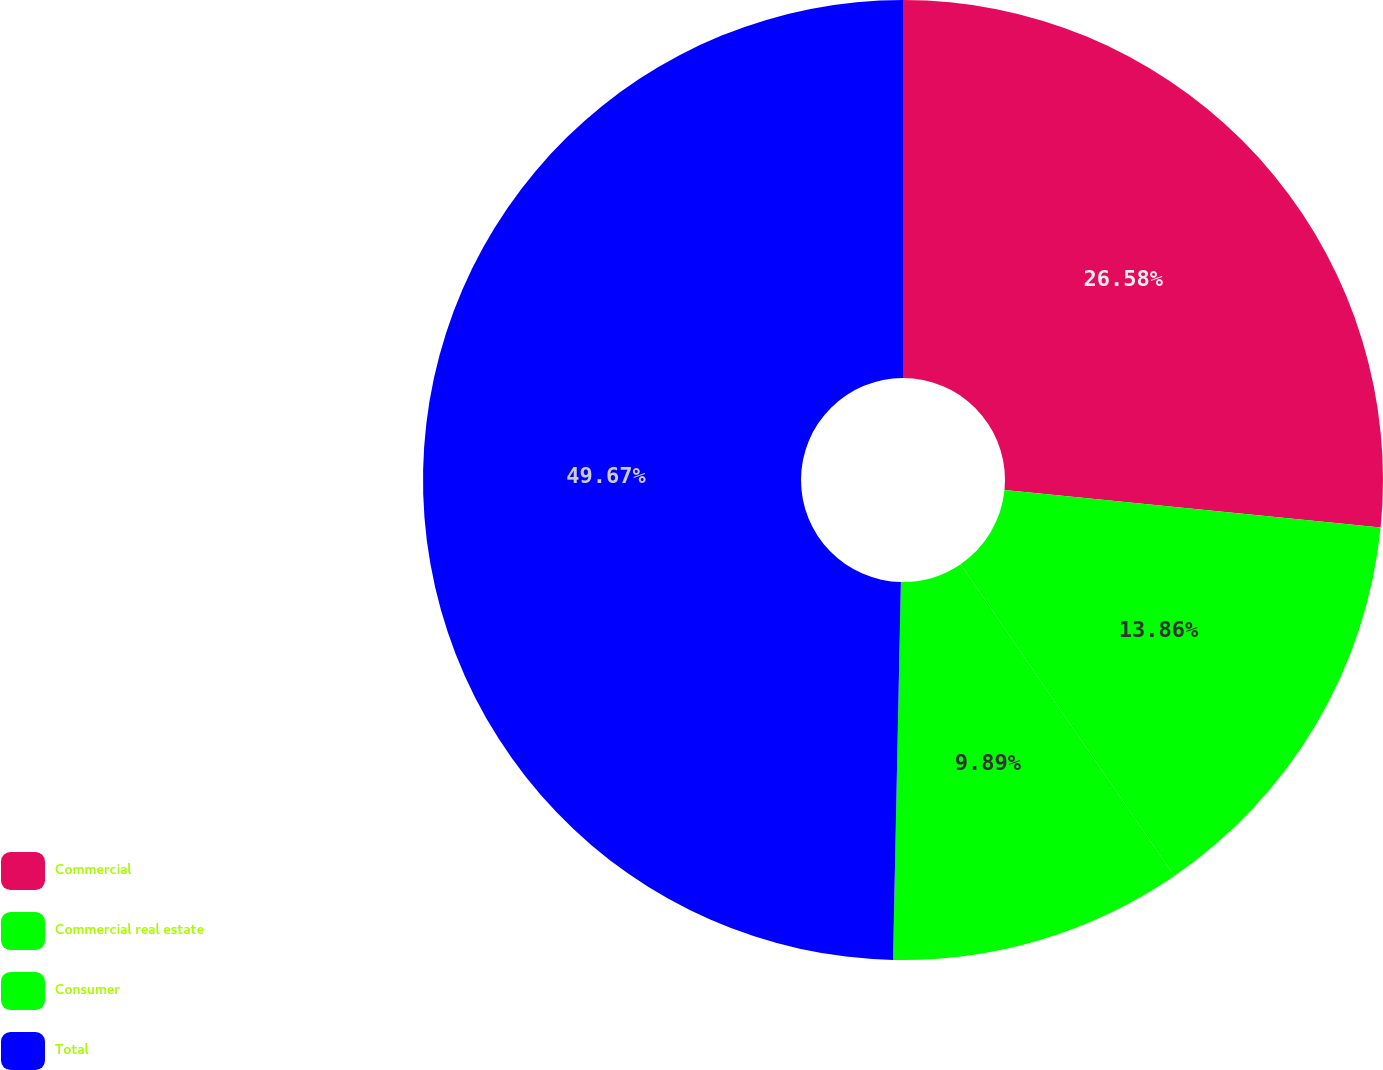Convert chart. <chart><loc_0><loc_0><loc_500><loc_500><pie_chart><fcel>Commercial<fcel>Commercial real estate<fcel>Consumer<fcel>Total<nl><fcel>26.58%<fcel>13.86%<fcel>9.89%<fcel>49.67%<nl></chart> 